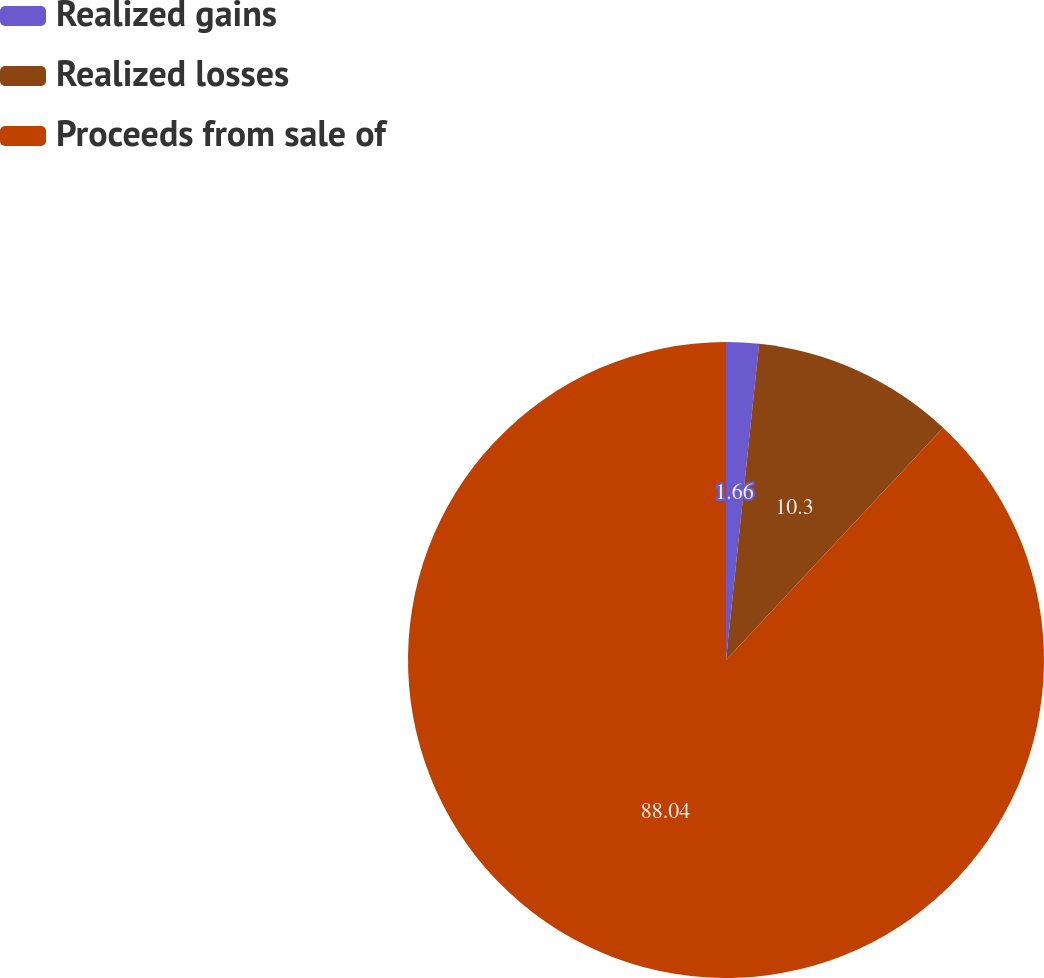<chart> <loc_0><loc_0><loc_500><loc_500><pie_chart><fcel>Realized gains<fcel>Realized losses<fcel>Proceeds from sale of<nl><fcel>1.66%<fcel>10.3%<fcel>88.04%<nl></chart> 